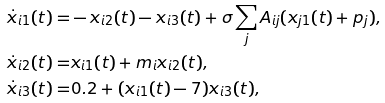Convert formula to latex. <formula><loc_0><loc_0><loc_500><loc_500>\dot { x } _ { i 1 } ( t ) = & - x _ { i 2 } ( t ) - x _ { i 3 } ( t ) + \sigma \sum _ { j } A _ { i j } ( x _ { j 1 } ( t ) + p _ { j } ) , \\ \dot { x } _ { i 2 } ( t ) = & x _ { i 1 } ( t ) + m _ { i } x _ { i 2 } ( t ) , \\ \dot { x } _ { i 3 } ( t ) = & 0 . 2 + ( x _ { i 1 } ( t ) - 7 ) x _ { i 3 } ( t ) ,</formula> 